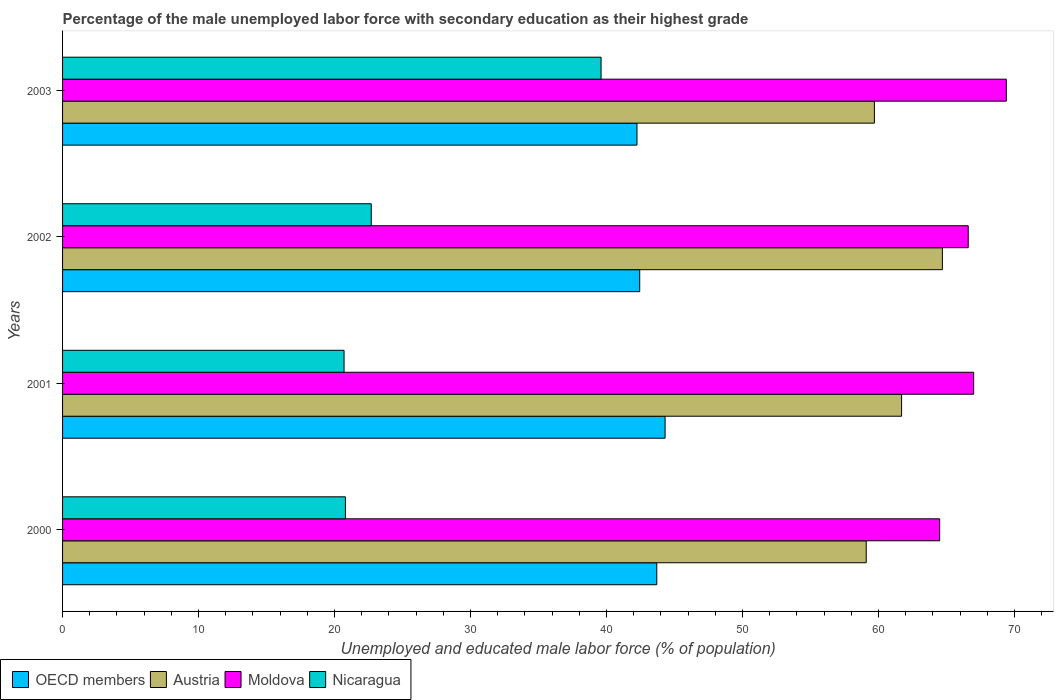How many different coloured bars are there?
Keep it short and to the point. 4. How many groups of bars are there?
Offer a very short reply. 4. Are the number of bars on each tick of the Y-axis equal?
Keep it short and to the point. Yes. How many bars are there on the 2nd tick from the top?
Make the answer very short. 4. How many bars are there on the 1st tick from the bottom?
Provide a short and direct response. 4. What is the label of the 2nd group of bars from the top?
Provide a succinct answer. 2002. In how many cases, is the number of bars for a given year not equal to the number of legend labels?
Keep it short and to the point. 0. What is the percentage of the unemployed male labor force with secondary education in Moldova in 2000?
Your response must be concise. 64.5. Across all years, what is the maximum percentage of the unemployed male labor force with secondary education in Nicaragua?
Offer a terse response. 39.6. Across all years, what is the minimum percentage of the unemployed male labor force with secondary education in Moldova?
Provide a succinct answer. 64.5. What is the total percentage of the unemployed male labor force with secondary education in OECD members in the graph?
Provide a short and direct response. 172.69. What is the difference between the percentage of the unemployed male labor force with secondary education in Austria in 2000 and that in 2001?
Your answer should be very brief. -2.6. What is the difference between the percentage of the unemployed male labor force with secondary education in OECD members in 2000 and the percentage of the unemployed male labor force with secondary education in Nicaragua in 2001?
Provide a succinct answer. 23. What is the average percentage of the unemployed male labor force with secondary education in Nicaragua per year?
Keep it short and to the point. 25.95. In the year 2003, what is the difference between the percentage of the unemployed male labor force with secondary education in Austria and percentage of the unemployed male labor force with secondary education in Moldova?
Offer a terse response. -9.7. What is the ratio of the percentage of the unemployed male labor force with secondary education in Nicaragua in 2001 to that in 2002?
Offer a very short reply. 0.91. Is the percentage of the unemployed male labor force with secondary education in OECD members in 2000 less than that in 2001?
Your response must be concise. Yes. Is the difference between the percentage of the unemployed male labor force with secondary education in Austria in 2001 and 2003 greater than the difference between the percentage of the unemployed male labor force with secondary education in Moldova in 2001 and 2003?
Your answer should be compact. Yes. What is the difference between the highest and the second highest percentage of the unemployed male labor force with secondary education in Moldova?
Give a very brief answer. 2.4. What is the difference between the highest and the lowest percentage of the unemployed male labor force with secondary education in Austria?
Your answer should be very brief. 5.6. In how many years, is the percentage of the unemployed male labor force with secondary education in Nicaragua greater than the average percentage of the unemployed male labor force with secondary education in Nicaragua taken over all years?
Keep it short and to the point. 1. What does the 4th bar from the bottom in 2002 represents?
Provide a succinct answer. Nicaragua. How many years are there in the graph?
Provide a short and direct response. 4. Does the graph contain any zero values?
Keep it short and to the point. No. Does the graph contain grids?
Provide a short and direct response. No. Where does the legend appear in the graph?
Ensure brevity in your answer.  Bottom left. How are the legend labels stacked?
Your response must be concise. Horizontal. What is the title of the graph?
Your answer should be compact. Percentage of the male unemployed labor force with secondary education as their highest grade. Does "Syrian Arab Republic" appear as one of the legend labels in the graph?
Give a very brief answer. No. What is the label or title of the X-axis?
Give a very brief answer. Unemployed and educated male labor force (% of population). What is the Unemployed and educated male labor force (% of population) of OECD members in 2000?
Your response must be concise. 43.7. What is the Unemployed and educated male labor force (% of population) in Austria in 2000?
Your answer should be very brief. 59.1. What is the Unemployed and educated male labor force (% of population) of Moldova in 2000?
Your answer should be very brief. 64.5. What is the Unemployed and educated male labor force (% of population) of Nicaragua in 2000?
Ensure brevity in your answer.  20.8. What is the Unemployed and educated male labor force (% of population) of OECD members in 2001?
Make the answer very short. 44.31. What is the Unemployed and educated male labor force (% of population) in Austria in 2001?
Offer a terse response. 61.7. What is the Unemployed and educated male labor force (% of population) in Nicaragua in 2001?
Offer a very short reply. 20.7. What is the Unemployed and educated male labor force (% of population) in OECD members in 2002?
Make the answer very short. 42.44. What is the Unemployed and educated male labor force (% of population) in Austria in 2002?
Give a very brief answer. 64.7. What is the Unemployed and educated male labor force (% of population) in Moldova in 2002?
Keep it short and to the point. 66.6. What is the Unemployed and educated male labor force (% of population) of Nicaragua in 2002?
Keep it short and to the point. 22.7. What is the Unemployed and educated male labor force (% of population) in OECD members in 2003?
Provide a succinct answer. 42.24. What is the Unemployed and educated male labor force (% of population) in Austria in 2003?
Your response must be concise. 59.7. What is the Unemployed and educated male labor force (% of population) of Moldova in 2003?
Your answer should be very brief. 69.4. What is the Unemployed and educated male labor force (% of population) in Nicaragua in 2003?
Ensure brevity in your answer.  39.6. Across all years, what is the maximum Unemployed and educated male labor force (% of population) of OECD members?
Your response must be concise. 44.31. Across all years, what is the maximum Unemployed and educated male labor force (% of population) of Austria?
Ensure brevity in your answer.  64.7. Across all years, what is the maximum Unemployed and educated male labor force (% of population) of Moldova?
Provide a succinct answer. 69.4. Across all years, what is the maximum Unemployed and educated male labor force (% of population) of Nicaragua?
Offer a very short reply. 39.6. Across all years, what is the minimum Unemployed and educated male labor force (% of population) in OECD members?
Give a very brief answer. 42.24. Across all years, what is the minimum Unemployed and educated male labor force (% of population) in Austria?
Ensure brevity in your answer.  59.1. Across all years, what is the minimum Unemployed and educated male labor force (% of population) in Moldova?
Your response must be concise. 64.5. Across all years, what is the minimum Unemployed and educated male labor force (% of population) of Nicaragua?
Give a very brief answer. 20.7. What is the total Unemployed and educated male labor force (% of population) of OECD members in the graph?
Keep it short and to the point. 172.69. What is the total Unemployed and educated male labor force (% of population) of Austria in the graph?
Give a very brief answer. 245.2. What is the total Unemployed and educated male labor force (% of population) in Moldova in the graph?
Make the answer very short. 267.5. What is the total Unemployed and educated male labor force (% of population) of Nicaragua in the graph?
Your response must be concise. 103.8. What is the difference between the Unemployed and educated male labor force (% of population) in OECD members in 2000 and that in 2001?
Ensure brevity in your answer.  -0.61. What is the difference between the Unemployed and educated male labor force (% of population) in Austria in 2000 and that in 2001?
Give a very brief answer. -2.6. What is the difference between the Unemployed and educated male labor force (% of population) of Nicaragua in 2000 and that in 2001?
Make the answer very short. 0.1. What is the difference between the Unemployed and educated male labor force (% of population) in OECD members in 2000 and that in 2002?
Ensure brevity in your answer.  1.25. What is the difference between the Unemployed and educated male labor force (% of population) of Austria in 2000 and that in 2002?
Your response must be concise. -5.6. What is the difference between the Unemployed and educated male labor force (% of population) in Moldova in 2000 and that in 2002?
Provide a succinct answer. -2.1. What is the difference between the Unemployed and educated male labor force (% of population) of OECD members in 2000 and that in 2003?
Ensure brevity in your answer.  1.46. What is the difference between the Unemployed and educated male labor force (% of population) of Nicaragua in 2000 and that in 2003?
Your answer should be very brief. -18.8. What is the difference between the Unemployed and educated male labor force (% of population) of OECD members in 2001 and that in 2002?
Offer a terse response. 1.87. What is the difference between the Unemployed and educated male labor force (% of population) in Moldova in 2001 and that in 2002?
Your answer should be compact. 0.4. What is the difference between the Unemployed and educated male labor force (% of population) of Nicaragua in 2001 and that in 2002?
Your answer should be very brief. -2. What is the difference between the Unemployed and educated male labor force (% of population) of OECD members in 2001 and that in 2003?
Keep it short and to the point. 2.07. What is the difference between the Unemployed and educated male labor force (% of population) of Nicaragua in 2001 and that in 2003?
Make the answer very short. -18.9. What is the difference between the Unemployed and educated male labor force (% of population) in OECD members in 2002 and that in 2003?
Offer a terse response. 0.2. What is the difference between the Unemployed and educated male labor force (% of population) in Nicaragua in 2002 and that in 2003?
Offer a terse response. -16.9. What is the difference between the Unemployed and educated male labor force (% of population) of OECD members in 2000 and the Unemployed and educated male labor force (% of population) of Austria in 2001?
Give a very brief answer. -18. What is the difference between the Unemployed and educated male labor force (% of population) of OECD members in 2000 and the Unemployed and educated male labor force (% of population) of Moldova in 2001?
Your answer should be compact. -23.3. What is the difference between the Unemployed and educated male labor force (% of population) of OECD members in 2000 and the Unemployed and educated male labor force (% of population) of Nicaragua in 2001?
Keep it short and to the point. 23. What is the difference between the Unemployed and educated male labor force (% of population) in Austria in 2000 and the Unemployed and educated male labor force (% of population) in Moldova in 2001?
Provide a succinct answer. -7.9. What is the difference between the Unemployed and educated male labor force (% of population) in Austria in 2000 and the Unemployed and educated male labor force (% of population) in Nicaragua in 2001?
Ensure brevity in your answer.  38.4. What is the difference between the Unemployed and educated male labor force (% of population) of Moldova in 2000 and the Unemployed and educated male labor force (% of population) of Nicaragua in 2001?
Your answer should be very brief. 43.8. What is the difference between the Unemployed and educated male labor force (% of population) in OECD members in 2000 and the Unemployed and educated male labor force (% of population) in Austria in 2002?
Your answer should be compact. -21. What is the difference between the Unemployed and educated male labor force (% of population) in OECD members in 2000 and the Unemployed and educated male labor force (% of population) in Moldova in 2002?
Offer a very short reply. -22.9. What is the difference between the Unemployed and educated male labor force (% of population) in OECD members in 2000 and the Unemployed and educated male labor force (% of population) in Nicaragua in 2002?
Provide a succinct answer. 21. What is the difference between the Unemployed and educated male labor force (% of population) of Austria in 2000 and the Unemployed and educated male labor force (% of population) of Moldova in 2002?
Provide a succinct answer. -7.5. What is the difference between the Unemployed and educated male labor force (% of population) of Austria in 2000 and the Unemployed and educated male labor force (% of population) of Nicaragua in 2002?
Offer a very short reply. 36.4. What is the difference between the Unemployed and educated male labor force (% of population) of Moldova in 2000 and the Unemployed and educated male labor force (% of population) of Nicaragua in 2002?
Provide a succinct answer. 41.8. What is the difference between the Unemployed and educated male labor force (% of population) of OECD members in 2000 and the Unemployed and educated male labor force (% of population) of Austria in 2003?
Keep it short and to the point. -16. What is the difference between the Unemployed and educated male labor force (% of population) of OECD members in 2000 and the Unemployed and educated male labor force (% of population) of Moldova in 2003?
Make the answer very short. -25.7. What is the difference between the Unemployed and educated male labor force (% of population) in OECD members in 2000 and the Unemployed and educated male labor force (% of population) in Nicaragua in 2003?
Make the answer very short. 4.1. What is the difference between the Unemployed and educated male labor force (% of population) in Moldova in 2000 and the Unemployed and educated male labor force (% of population) in Nicaragua in 2003?
Your response must be concise. 24.9. What is the difference between the Unemployed and educated male labor force (% of population) in OECD members in 2001 and the Unemployed and educated male labor force (% of population) in Austria in 2002?
Your answer should be compact. -20.39. What is the difference between the Unemployed and educated male labor force (% of population) in OECD members in 2001 and the Unemployed and educated male labor force (% of population) in Moldova in 2002?
Give a very brief answer. -22.29. What is the difference between the Unemployed and educated male labor force (% of population) in OECD members in 2001 and the Unemployed and educated male labor force (% of population) in Nicaragua in 2002?
Keep it short and to the point. 21.61. What is the difference between the Unemployed and educated male labor force (% of population) in Moldova in 2001 and the Unemployed and educated male labor force (% of population) in Nicaragua in 2002?
Your answer should be very brief. 44.3. What is the difference between the Unemployed and educated male labor force (% of population) in OECD members in 2001 and the Unemployed and educated male labor force (% of population) in Austria in 2003?
Offer a terse response. -15.39. What is the difference between the Unemployed and educated male labor force (% of population) in OECD members in 2001 and the Unemployed and educated male labor force (% of population) in Moldova in 2003?
Provide a succinct answer. -25.09. What is the difference between the Unemployed and educated male labor force (% of population) of OECD members in 2001 and the Unemployed and educated male labor force (% of population) of Nicaragua in 2003?
Make the answer very short. 4.71. What is the difference between the Unemployed and educated male labor force (% of population) of Austria in 2001 and the Unemployed and educated male labor force (% of population) of Moldova in 2003?
Keep it short and to the point. -7.7. What is the difference between the Unemployed and educated male labor force (% of population) of Austria in 2001 and the Unemployed and educated male labor force (% of population) of Nicaragua in 2003?
Your response must be concise. 22.1. What is the difference between the Unemployed and educated male labor force (% of population) of Moldova in 2001 and the Unemployed and educated male labor force (% of population) of Nicaragua in 2003?
Provide a succinct answer. 27.4. What is the difference between the Unemployed and educated male labor force (% of population) of OECD members in 2002 and the Unemployed and educated male labor force (% of population) of Austria in 2003?
Offer a very short reply. -17.26. What is the difference between the Unemployed and educated male labor force (% of population) in OECD members in 2002 and the Unemployed and educated male labor force (% of population) in Moldova in 2003?
Provide a short and direct response. -26.96. What is the difference between the Unemployed and educated male labor force (% of population) in OECD members in 2002 and the Unemployed and educated male labor force (% of population) in Nicaragua in 2003?
Make the answer very short. 2.84. What is the difference between the Unemployed and educated male labor force (% of population) in Austria in 2002 and the Unemployed and educated male labor force (% of population) in Nicaragua in 2003?
Your answer should be compact. 25.1. What is the difference between the Unemployed and educated male labor force (% of population) of Moldova in 2002 and the Unemployed and educated male labor force (% of population) of Nicaragua in 2003?
Make the answer very short. 27. What is the average Unemployed and educated male labor force (% of population) in OECD members per year?
Give a very brief answer. 43.17. What is the average Unemployed and educated male labor force (% of population) of Austria per year?
Keep it short and to the point. 61.3. What is the average Unemployed and educated male labor force (% of population) in Moldova per year?
Offer a terse response. 66.88. What is the average Unemployed and educated male labor force (% of population) in Nicaragua per year?
Give a very brief answer. 25.95. In the year 2000, what is the difference between the Unemployed and educated male labor force (% of population) in OECD members and Unemployed and educated male labor force (% of population) in Austria?
Your response must be concise. -15.4. In the year 2000, what is the difference between the Unemployed and educated male labor force (% of population) in OECD members and Unemployed and educated male labor force (% of population) in Moldova?
Offer a terse response. -20.8. In the year 2000, what is the difference between the Unemployed and educated male labor force (% of population) in OECD members and Unemployed and educated male labor force (% of population) in Nicaragua?
Offer a terse response. 22.9. In the year 2000, what is the difference between the Unemployed and educated male labor force (% of population) of Austria and Unemployed and educated male labor force (% of population) of Nicaragua?
Your answer should be very brief. 38.3. In the year 2000, what is the difference between the Unemployed and educated male labor force (% of population) in Moldova and Unemployed and educated male labor force (% of population) in Nicaragua?
Your answer should be very brief. 43.7. In the year 2001, what is the difference between the Unemployed and educated male labor force (% of population) of OECD members and Unemployed and educated male labor force (% of population) of Austria?
Provide a short and direct response. -17.39. In the year 2001, what is the difference between the Unemployed and educated male labor force (% of population) of OECD members and Unemployed and educated male labor force (% of population) of Moldova?
Offer a terse response. -22.69. In the year 2001, what is the difference between the Unemployed and educated male labor force (% of population) of OECD members and Unemployed and educated male labor force (% of population) of Nicaragua?
Offer a terse response. 23.61. In the year 2001, what is the difference between the Unemployed and educated male labor force (% of population) of Austria and Unemployed and educated male labor force (% of population) of Nicaragua?
Offer a terse response. 41. In the year 2001, what is the difference between the Unemployed and educated male labor force (% of population) of Moldova and Unemployed and educated male labor force (% of population) of Nicaragua?
Your response must be concise. 46.3. In the year 2002, what is the difference between the Unemployed and educated male labor force (% of population) of OECD members and Unemployed and educated male labor force (% of population) of Austria?
Make the answer very short. -22.26. In the year 2002, what is the difference between the Unemployed and educated male labor force (% of population) of OECD members and Unemployed and educated male labor force (% of population) of Moldova?
Provide a short and direct response. -24.16. In the year 2002, what is the difference between the Unemployed and educated male labor force (% of population) of OECD members and Unemployed and educated male labor force (% of population) of Nicaragua?
Provide a succinct answer. 19.74. In the year 2002, what is the difference between the Unemployed and educated male labor force (% of population) in Austria and Unemployed and educated male labor force (% of population) in Moldova?
Ensure brevity in your answer.  -1.9. In the year 2002, what is the difference between the Unemployed and educated male labor force (% of population) of Austria and Unemployed and educated male labor force (% of population) of Nicaragua?
Ensure brevity in your answer.  42. In the year 2002, what is the difference between the Unemployed and educated male labor force (% of population) in Moldova and Unemployed and educated male labor force (% of population) in Nicaragua?
Provide a short and direct response. 43.9. In the year 2003, what is the difference between the Unemployed and educated male labor force (% of population) in OECD members and Unemployed and educated male labor force (% of population) in Austria?
Your response must be concise. -17.46. In the year 2003, what is the difference between the Unemployed and educated male labor force (% of population) in OECD members and Unemployed and educated male labor force (% of population) in Moldova?
Keep it short and to the point. -27.16. In the year 2003, what is the difference between the Unemployed and educated male labor force (% of population) of OECD members and Unemployed and educated male labor force (% of population) of Nicaragua?
Provide a short and direct response. 2.64. In the year 2003, what is the difference between the Unemployed and educated male labor force (% of population) of Austria and Unemployed and educated male labor force (% of population) of Nicaragua?
Your answer should be very brief. 20.1. In the year 2003, what is the difference between the Unemployed and educated male labor force (% of population) in Moldova and Unemployed and educated male labor force (% of population) in Nicaragua?
Keep it short and to the point. 29.8. What is the ratio of the Unemployed and educated male labor force (% of population) in OECD members in 2000 to that in 2001?
Your response must be concise. 0.99. What is the ratio of the Unemployed and educated male labor force (% of population) in Austria in 2000 to that in 2001?
Offer a very short reply. 0.96. What is the ratio of the Unemployed and educated male labor force (% of population) in Moldova in 2000 to that in 2001?
Give a very brief answer. 0.96. What is the ratio of the Unemployed and educated male labor force (% of population) of OECD members in 2000 to that in 2002?
Your answer should be compact. 1.03. What is the ratio of the Unemployed and educated male labor force (% of population) in Austria in 2000 to that in 2002?
Your response must be concise. 0.91. What is the ratio of the Unemployed and educated male labor force (% of population) of Moldova in 2000 to that in 2002?
Your response must be concise. 0.97. What is the ratio of the Unemployed and educated male labor force (% of population) of Nicaragua in 2000 to that in 2002?
Provide a succinct answer. 0.92. What is the ratio of the Unemployed and educated male labor force (% of population) of OECD members in 2000 to that in 2003?
Keep it short and to the point. 1.03. What is the ratio of the Unemployed and educated male labor force (% of population) in Austria in 2000 to that in 2003?
Offer a terse response. 0.99. What is the ratio of the Unemployed and educated male labor force (% of population) in Moldova in 2000 to that in 2003?
Make the answer very short. 0.93. What is the ratio of the Unemployed and educated male labor force (% of population) of Nicaragua in 2000 to that in 2003?
Offer a terse response. 0.53. What is the ratio of the Unemployed and educated male labor force (% of population) in OECD members in 2001 to that in 2002?
Keep it short and to the point. 1.04. What is the ratio of the Unemployed and educated male labor force (% of population) of Austria in 2001 to that in 2002?
Offer a very short reply. 0.95. What is the ratio of the Unemployed and educated male labor force (% of population) in Nicaragua in 2001 to that in 2002?
Provide a short and direct response. 0.91. What is the ratio of the Unemployed and educated male labor force (% of population) of OECD members in 2001 to that in 2003?
Your answer should be very brief. 1.05. What is the ratio of the Unemployed and educated male labor force (% of population) in Austria in 2001 to that in 2003?
Your answer should be compact. 1.03. What is the ratio of the Unemployed and educated male labor force (% of population) of Moldova in 2001 to that in 2003?
Provide a succinct answer. 0.97. What is the ratio of the Unemployed and educated male labor force (% of population) of Nicaragua in 2001 to that in 2003?
Provide a short and direct response. 0.52. What is the ratio of the Unemployed and educated male labor force (% of population) in OECD members in 2002 to that in 2003?
Your answer should be compact. 1. What is the ratio of the Unemployed and educated male labor force (% of population) of Austria in 2002 to that in 2003?
Your answer should be compact. 1.08. What is the ratio of the Unemployed and educated male labor force (% of population) of Moldova in 2002 to that in 2003?
Give a very brief answer. 0.96. What is the ratio of the Unemployed and educated male labor force (% of population) in Nicaragua in 2002 to that in 2003?
Give a very brief answer. 0.57. What is the difference between the highest and the second highest Unemployed and educated male labor force (% of population) of OECD members?
Your answer should be very brief. 0.61. What is the difference between the highest and the second highest Unemployed and educated male labor force (% of population) of Austria?
Offer a very short reply. 3. What is the difference between the highest and the second highest Unemployed and educated male labor force (% of population) in Nicaragua?
Your answer should be very brief. 16.9. What is the difference between the highest and the lowest Unemployed and educated male labor force (% of population) of OECD members?
Your answer should be compact. 2.07. What is the difference between the highest and the lowest Unemployed and educated male labor force (% of population) of Austria?
Provide a short and direct response. 5.6. 